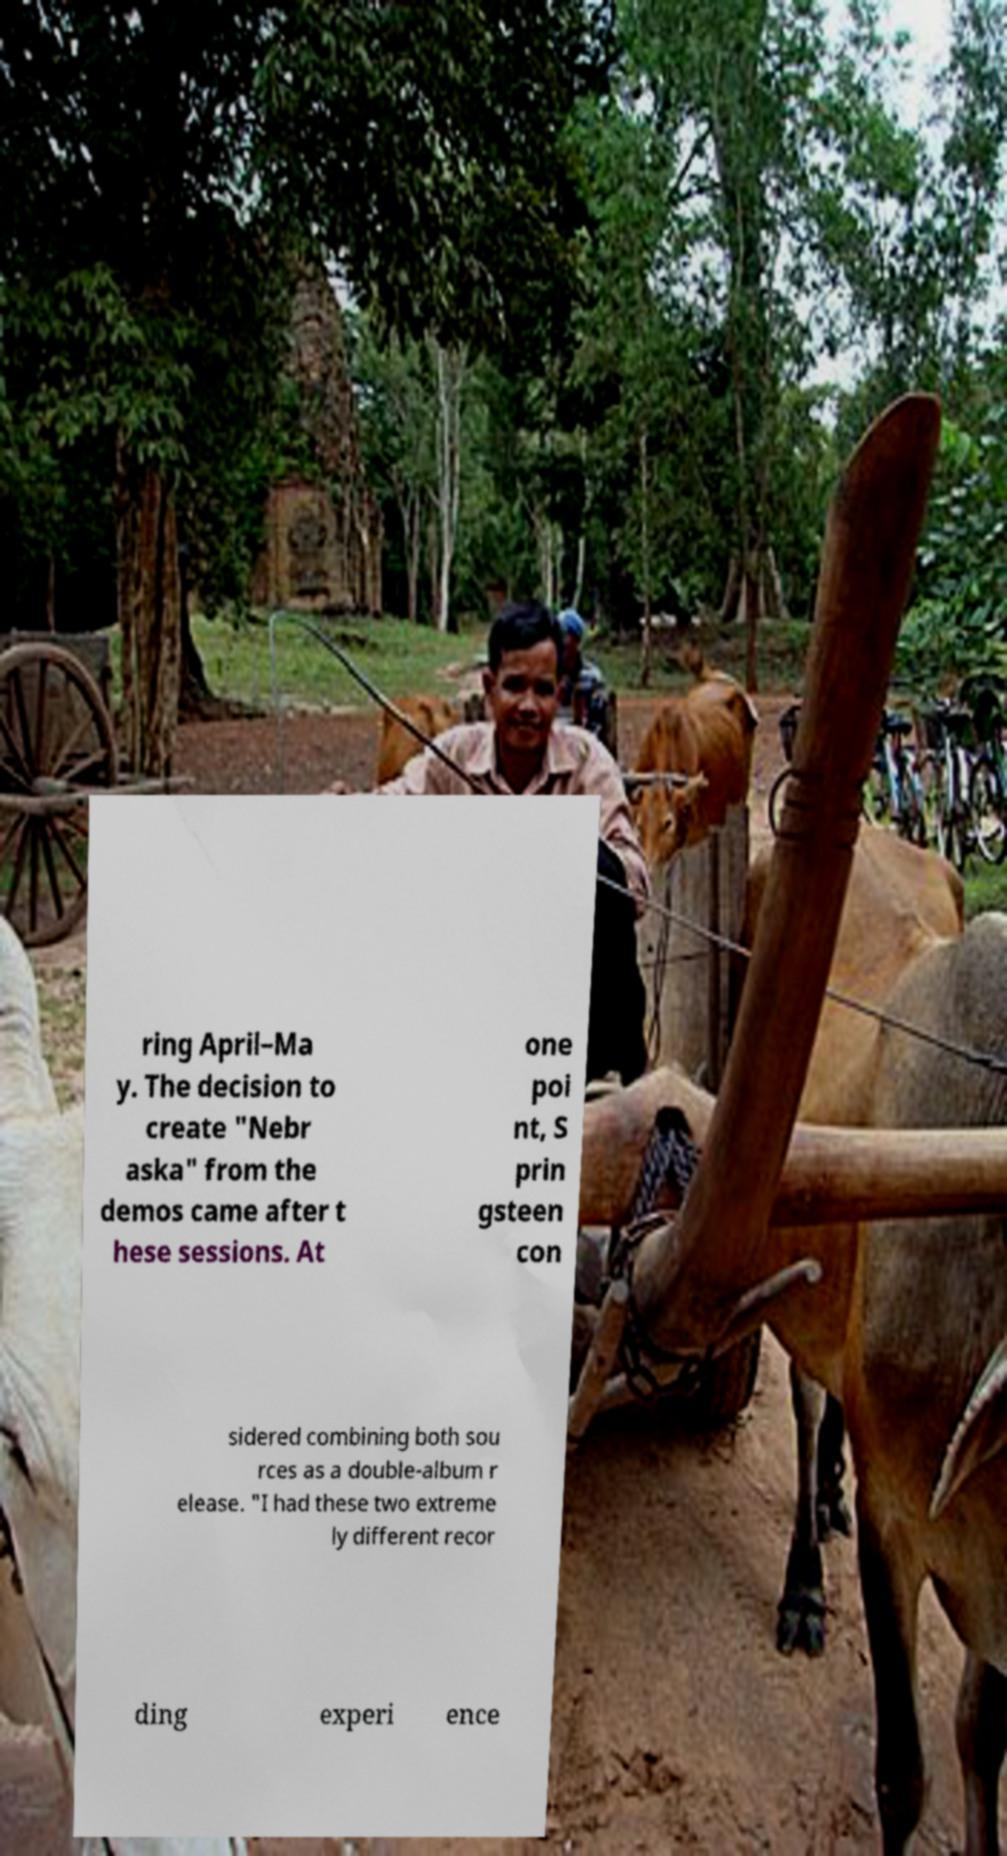Can you accurately transcribe the text from the provided image for me? ring April–Ma y. The decision to create "Nebr aska" from the demos came after t hese sessions. At one poi nt, S prin gsteen con sidered combining both sou rces as a double-album r elease. "I had these two extreme ly different recor ding experi ence 